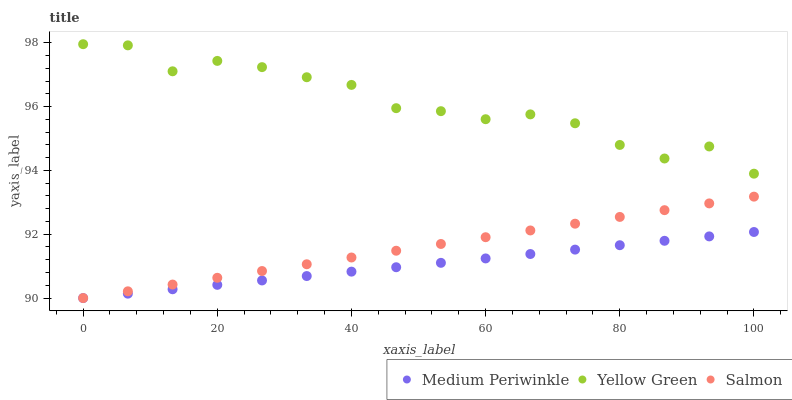Does Medium Periwinkle have the minimum area under the curve?
Answer yes or no. Yes. Does Yellow Green have the maximum area under the curve?
Answer yes or no. Yes. Does Yellow Green have the minimum area under the curve?
Answer yes or no. No. Does Medium Periwinkle have the maximum area under the curve?
Answer yes or no. No. Is Medium Periwinkle the smoothest?
Answer yes or no. Yes. Is Yellow Green the roughest?
Answer yes or no. Yes. Is Yellow Green the smoothest?
Answer yes or no. No. Is Medium Periwinkle the roughest?
Answer yes or no. No. Does Salmon have the lowest value?
Answer yes or no. Yes. Does Yellow Green have the lowest value?
Answer yes or no. No. Does Yellow Green have the highest value?
Answer yes or no. Yes. Does Medium Periwinkle have the highest value?
Answer yes or no. No. Is Medium Periwinkle less than Yellow Green?
Answer yes or no. Yes. Is Yellow Green greater than Salmon?
Answer yes or no. Yes. Does Medium Periwinkle intersect Salmon?
Answer yes or no. Yes. Is Medium Periwinkle less than Salmon?
Answer yes or no. No. Is Medium Periwinkle greater than Salmon?
Answer yes or no. No. Does Medium Periwinkle intersect Yellow Green?
Answer yes or no. No. 